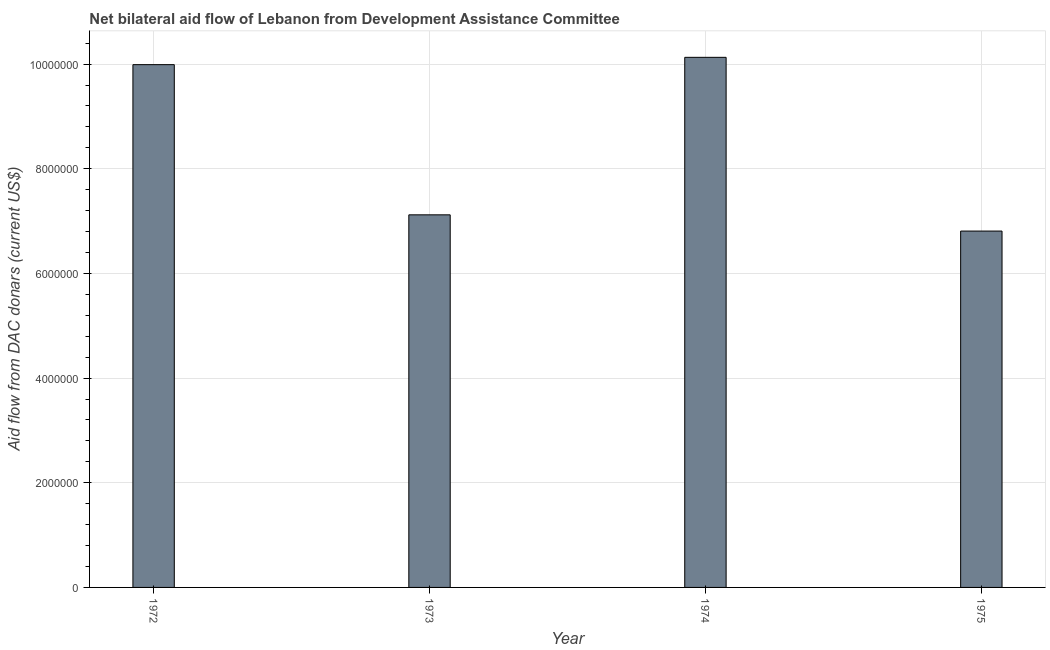Does the graph contain any zero values?
Offer a very short reply. No. What is the title of the graph?
Give a very brief answer. Net bilateral aid flow of Lebanon from Development Assistance Committee. What is the label or title of the Y-axis?
Your answer should be compact. Aid flow from DAC donars (current US$). What is the net bilateral aid flows from dac donors in 1973?
Ensure brevity in your answer.  7.12e+06. Across all years, what is the maximum net bilateral aid flows from dac donors?
Provide a short and direct response. 1.01e+07. Across all years, what is the minimum net bilateral aid flows from dac donors?
Give a very brief answer. 6.81e+06. In which year was the net bilateral aid flows from dac donors maximum?
Your response must be concise. 1974. In which year was the net bilateral aid flows from dac donors minimum?
Offer a very short reply. 1975. What is the sum of the net bilateral aid flows from dac donors?
Make the answer very short. 3.40e+07. What is the difference between the net bilateral aid flows from dac donors in 1973 and 1975?
Provide a succinct answer. 3.10e+05. What is the average net bilateral aid flows from dac donors per year?
Ensure brevity in your answer.  8.51e+06. What is the median net bilateral aid flows from dac donors?
Make the answer very short. 8.56e+06. In how many years, is the net bilateral aid flows from dac donors greater than 6400000 US$?
Offer a terse response. 4. What is the ratio of the net bilateral aid flows from dac donors in 1973 to that in 1974?
Give a very brief answer. 0.7. What is the difference between the highest and the lowest net bilateral aid flows from dac donors?
Keep it short and to the point. 3.32e+06. In how many years, is the net bilateral aid flows from dac donors greater than the average net bilateral aid flows from dac donors taken over all years?
Offer a terse response. 2. How many bars are there?
Your response must be concise. 4. How many years are there in the graph?
Make the answer very short. 4. What is the Aid flow from DAC donars (current US$) of 1972?
Offer a very short reply. 9.99e+06. What is the Aid flow from DAC donars (current US$) of 1973?
Offer a very short reply. 7.12e+06. What is the Aid flow from DAC donars (current US$) in 1974?
Your answer should be compact. 1.01e+07. What is the Aid flow from DAC donars (current US$) in 1975?
Offer a very short reply. 6.81e+06. What is the difference between the Aid flow from DAC donars (current US$) in 1972 and 1973?
Offer a very short reply. 2.87e+06. What is the difference between the Aid flow from DAC donars (current US$) in 1972 and 1974?
Provide a short and direct response. -1.40e+05. What is the difference between the Aid flow from DAC donars (current US$) in 1972 and 1975?
Offer a very short reply. 3.18e+06. What is the difference between the Aid flow from DAC donars (current US$) in 1973 and 1974?
Provide a succinct answer. -3.01e+06. What is the difference between the Aid flow from DAC donars (current US$) in 1974 and 1975?
Your answer should be very brief. 3.32e+06. What is the ratio of the Aid flow from DAC donars (current US$) in 1972 to that in 1973?
Your answer should be very brief. 1.4. What is the ratio of the Aid flow from DAC donars (current US$) in 1972 to that in 1975?
Give a very brief answer. 1.47. What is the ratio of the Aid flow from DAC donars (current US$) in 1973 to that in 1974?
Your response must be concise. 0.7. What is the ratio of the Aid flow from DAC donars (current US$) in 1973 to that in 1975?
Your response must be concise. 1.05. What is the ratio of the Aid flow from DAC donars (current US$) in 1974 to that in 1975?
Provide a succinct answer. 1.49. 